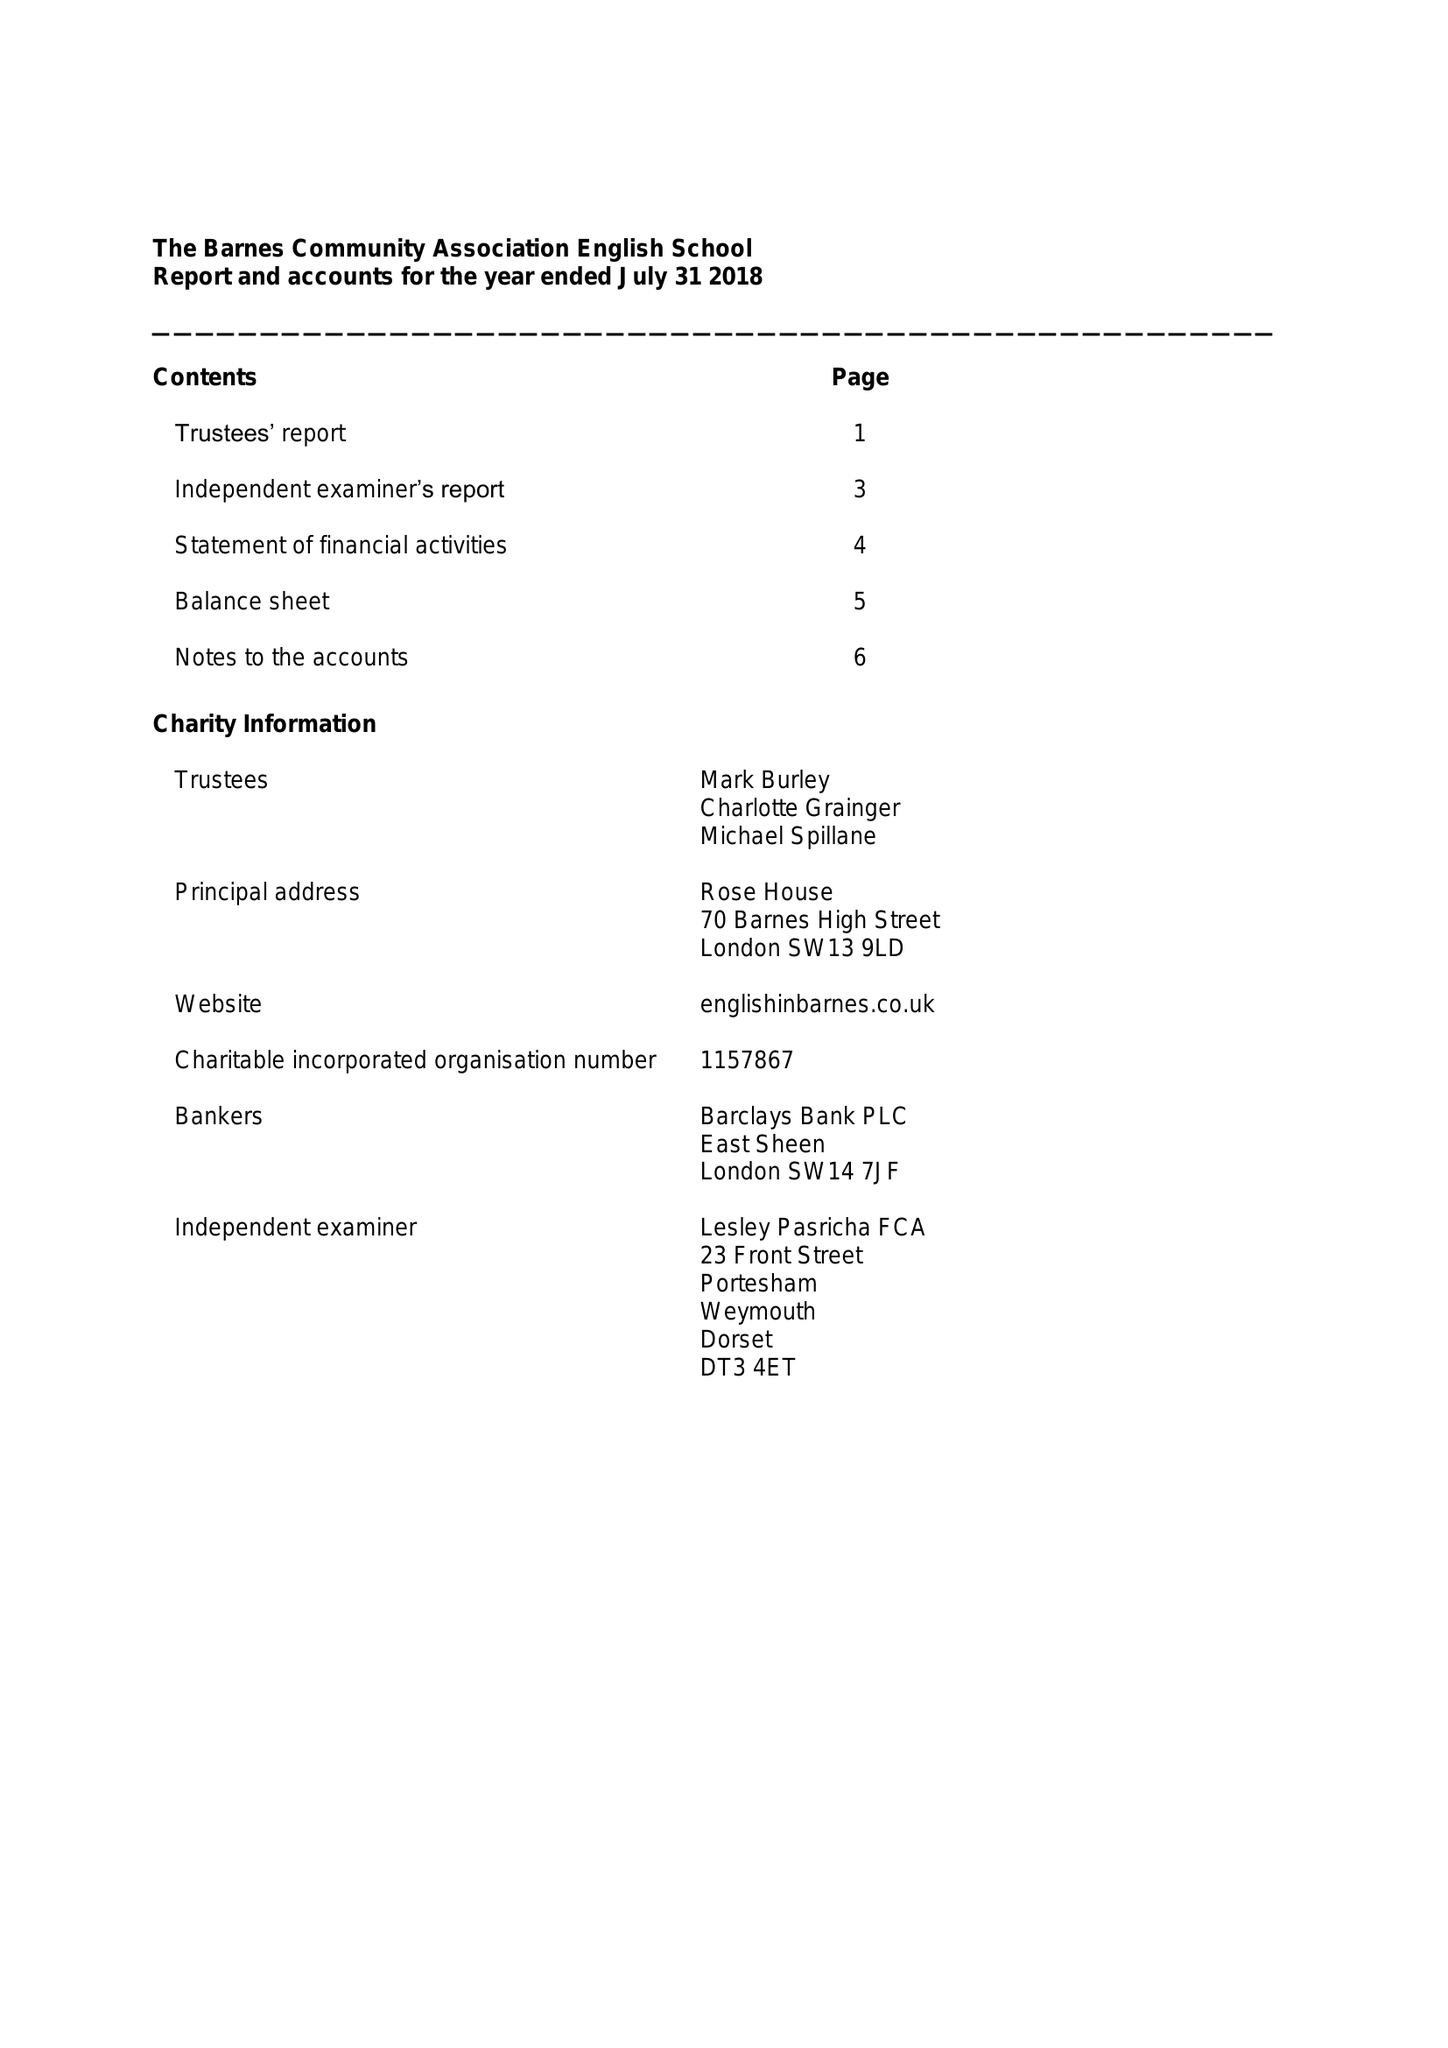What is the value for the charity_name?
Answer the question using a single word or phrase. The Barnes Community Association English School 